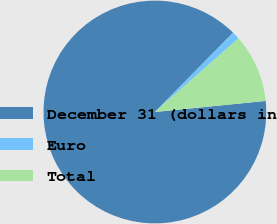Convert chart. <chart><loc_0><loc_0><loc_500><loc_500><pie_chart><fcel>December 31 (dollars in<fcel>Euro<fcel>Total<nl><fcel>88.97%<fcel>1.12%<fcel>9.91%<nl></chart> 